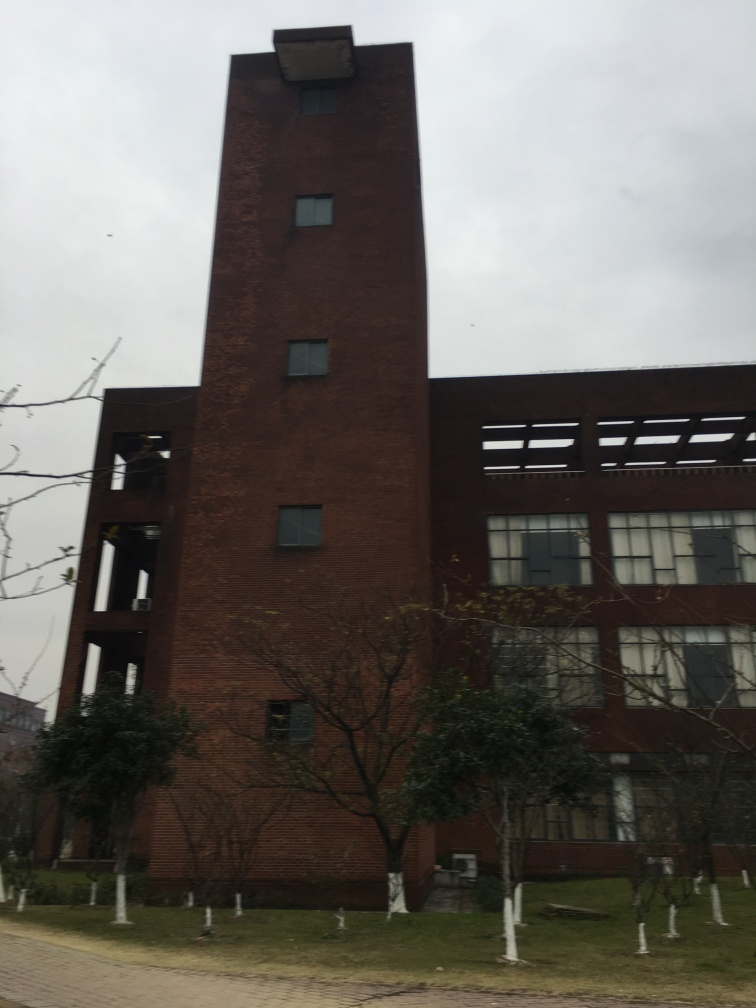Is the quality of this photo unacceptable?
A. Yes
B. No While the photo may not meet professional standards due to slight blurriness and dull lighting, it is generally acceptable for casual use as the main subject – the building – is visible. However, for purposes that require high-resolution or detailed architectural scrutiny, the quality may be considered below par. 